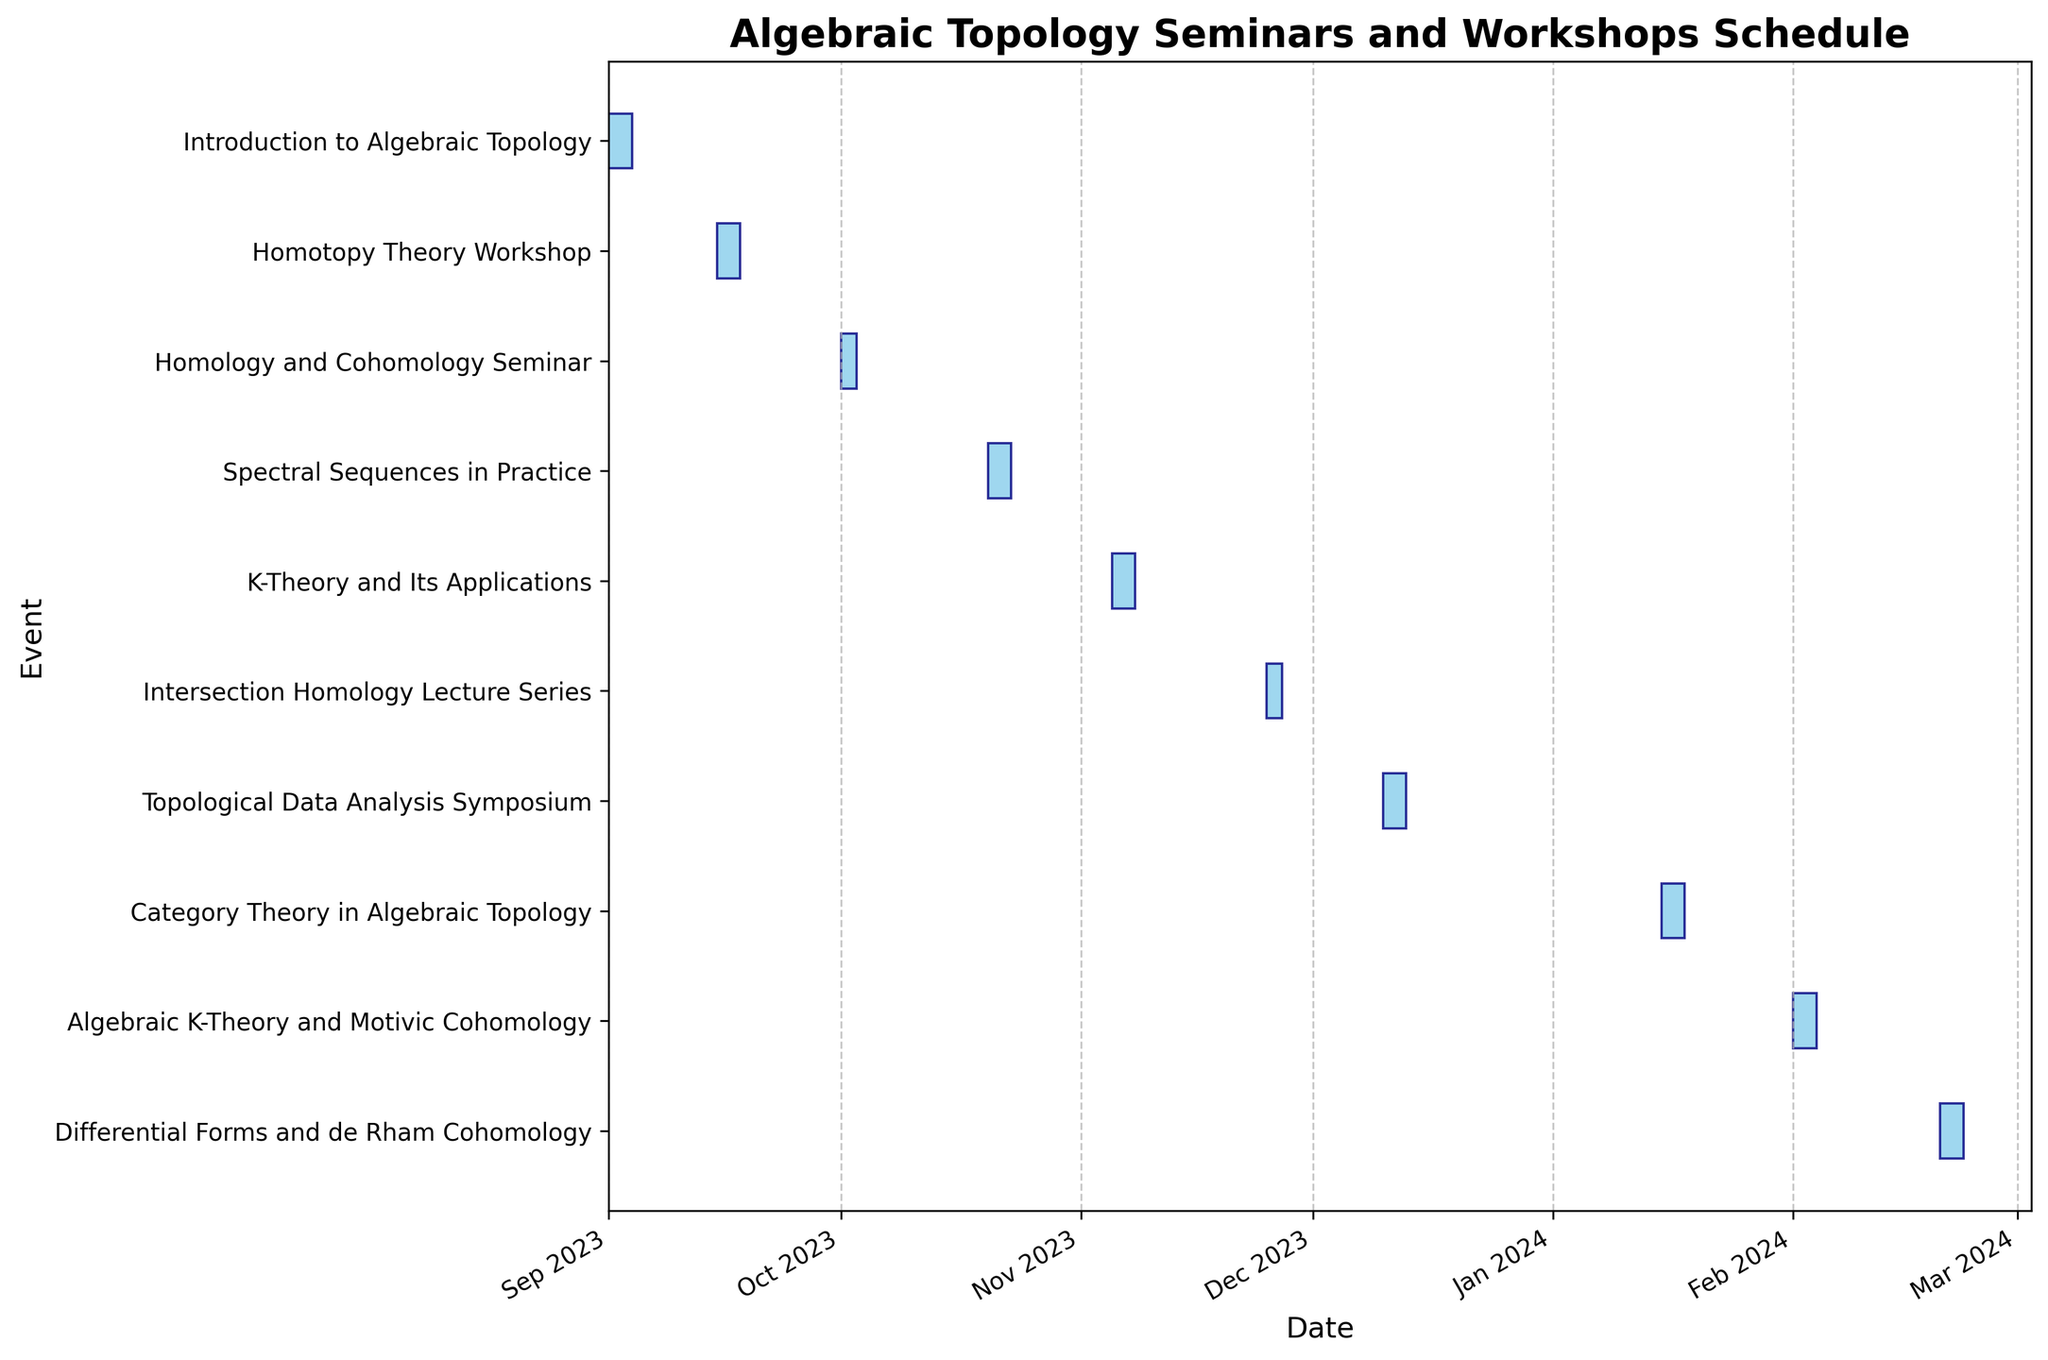What is the title of the Gantt chart? The title is usually found at the top of the chart and gives a brief summary of what the chart represents.
Answer: Algebraic Topology Seminars and Workshops Schedule When does the first event start and when does it end? The first event is the first bar on the chart which usually starts at the earliest date on the x-axis. It ends at the end of the corresponding bar.
Answer: Starts on 2023-09-01, Ends on 2023-09-03 How many events last exactly 3 days? Count the number of horizontal bars that span exactly 3 days along the x-axis.
Answer: Six events Which event occurs last in the schedule? The last event is the bar that appears furthest to the right on the x-axis.
Answer: Differential Forms and de Rham Cohomology How many events are scheduled in December 2023? Look for bars corresponding to events within the December section of the x-axis. Count these bars.
Answer: One event Which event spans the shortest duration? Identify the shortest bar along the x-axis, and check the corresponding event on the y-axis.
Answer: Homology and Cohomology Seminar and Intersection Homology Lecture Series Which months have no scheduled events? Examine the gaps on the x-axis where no bars are present and check the corresponding months.
Answer: None Compare the durations of 'Homotopy Theory Workshop' and 'Spectral Sequences in Practice'. Which one is longer? Measure the lengths of the bars representing these events and compare them. Both have the same durations.
Answer: They are equal (both 3 days) How many events are scheduled in November 2023? Identify bars that fall within the November month on the x-axis and count them.
Answer: Two events Which two events have the shortest time gap between their end and start dates? Calculate the time gaps between successive bars and identify the shortest gap.
Answer: Intersection Homology Lecture Series and Topological Data Analysis Symposium 